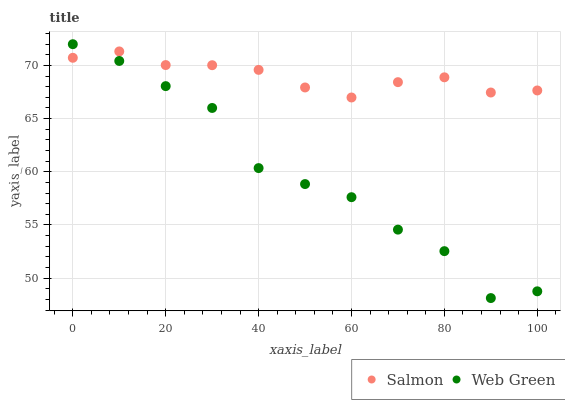Does Web Green have the minimum area under the curve?
Answer yes or no. Yes. Does Salmon have the maximum area under the curve?
Answer yes or no. Yes. Does Web Green have the maximum area under the curve?
Answer yes or no. No. Is Salmon the smoothest?
Answer yes or no. Yes. Is Web Green the roughest?
Answer yes or no. Yes. Is Web Green the smoothest?
Answer yes or no. No. Does Web Green have the lowest value?
Answer yes or no. Yes. Does Web Green have the highest value?
Answer yes or no. Yes. Does Web Green intersect Salmon?
Answer yes or no. Yes. Is Web Green less than Salmon?
Answer yes or no. No. Is Web Green greater than Salmon?
Answer yes or no. No. 